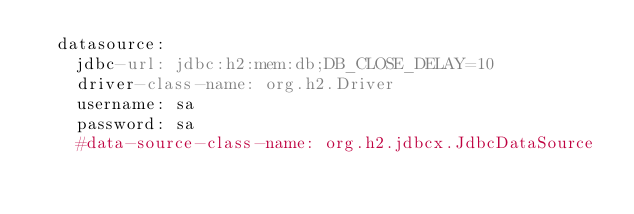Convert code to text. <code><loc_0><loc_0><loc_500><loc_500><_YAML_>  datasource:
    jdbc-url: jdbc:h2:mem:db;DB_CLOSE_DELAY=10
    driver-class-name: org.h2.Driver
    username: sa
    password: sa
    #data-source-class-name: org.h2.jdbcx.JdbcDataSource
</code> 